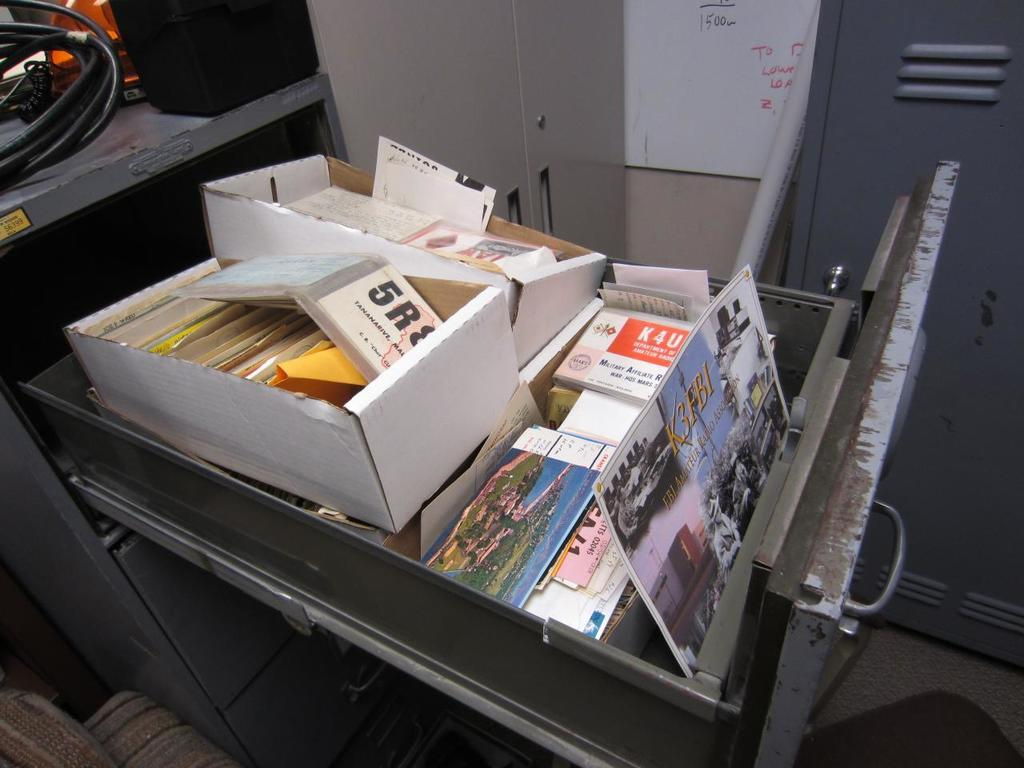<image>
Present a compact description of the photo's key features. A drawer full of cards and boxes has numbers such as 5R and K4U on them. 